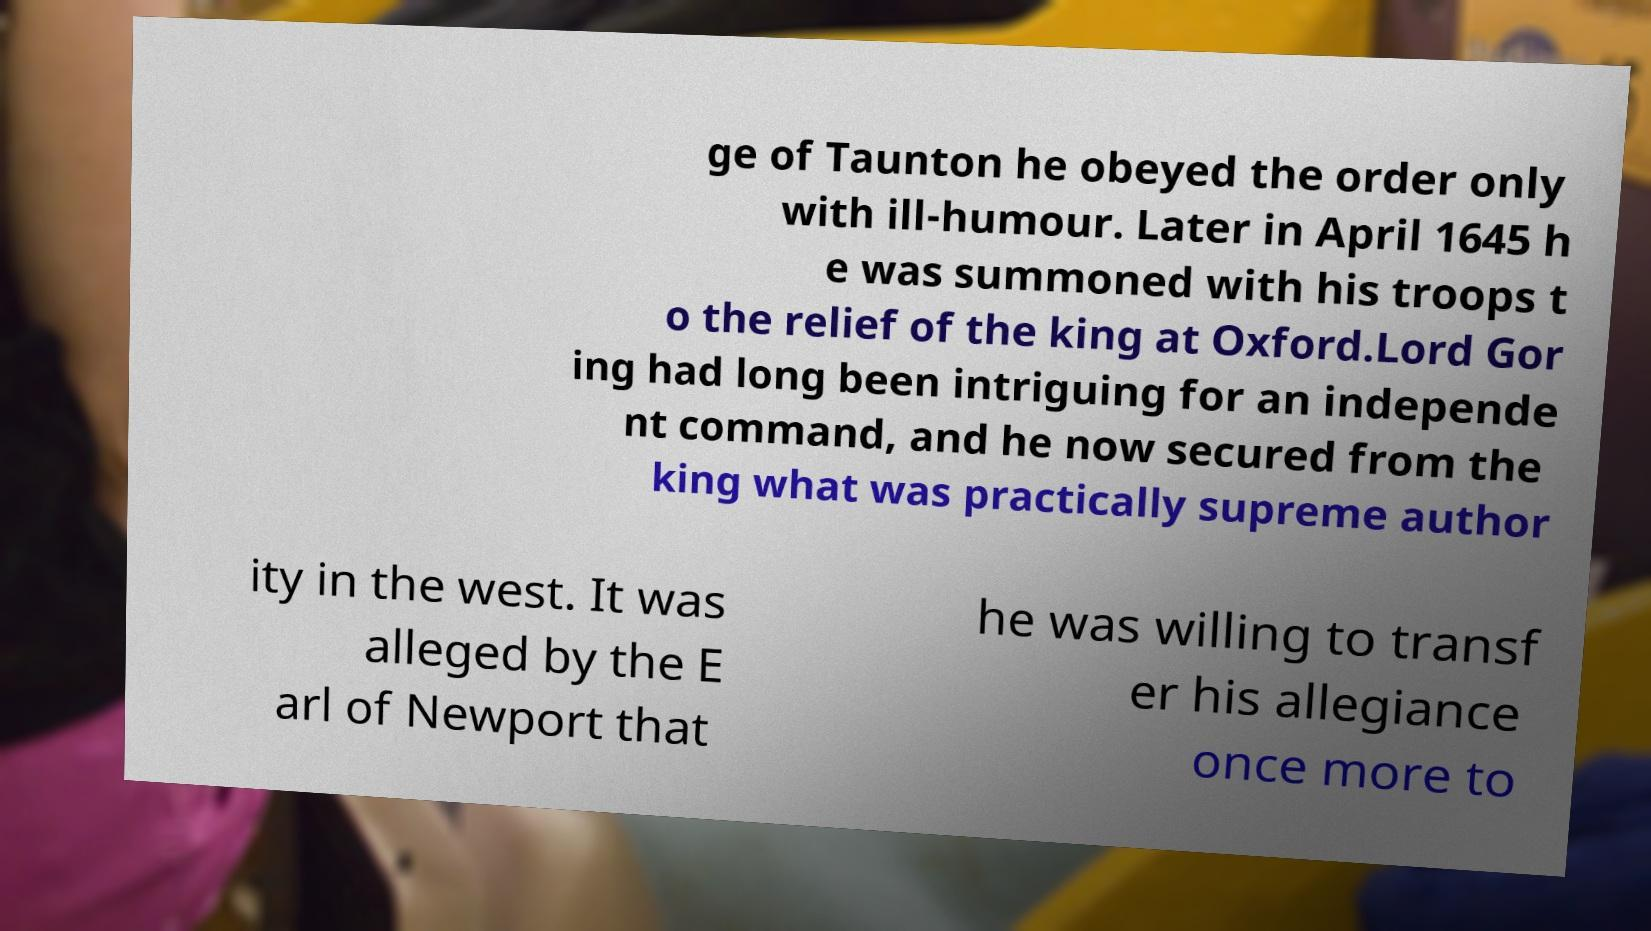For documentation purposes, I need the text within this image transcribed. Could you provide that? ge of Taunton he obeyed the order only with ill-humour. Later in April 1645 h e was summoned with his troops t o the relief of the king at Oxford.Lord Gor ing had long been intriguing for an independe nt command, and he now secured from the king what was practically supreme author ity in the west. It was alleged by the E arl of Newport that he was willing to transf er his allegiance once more to 